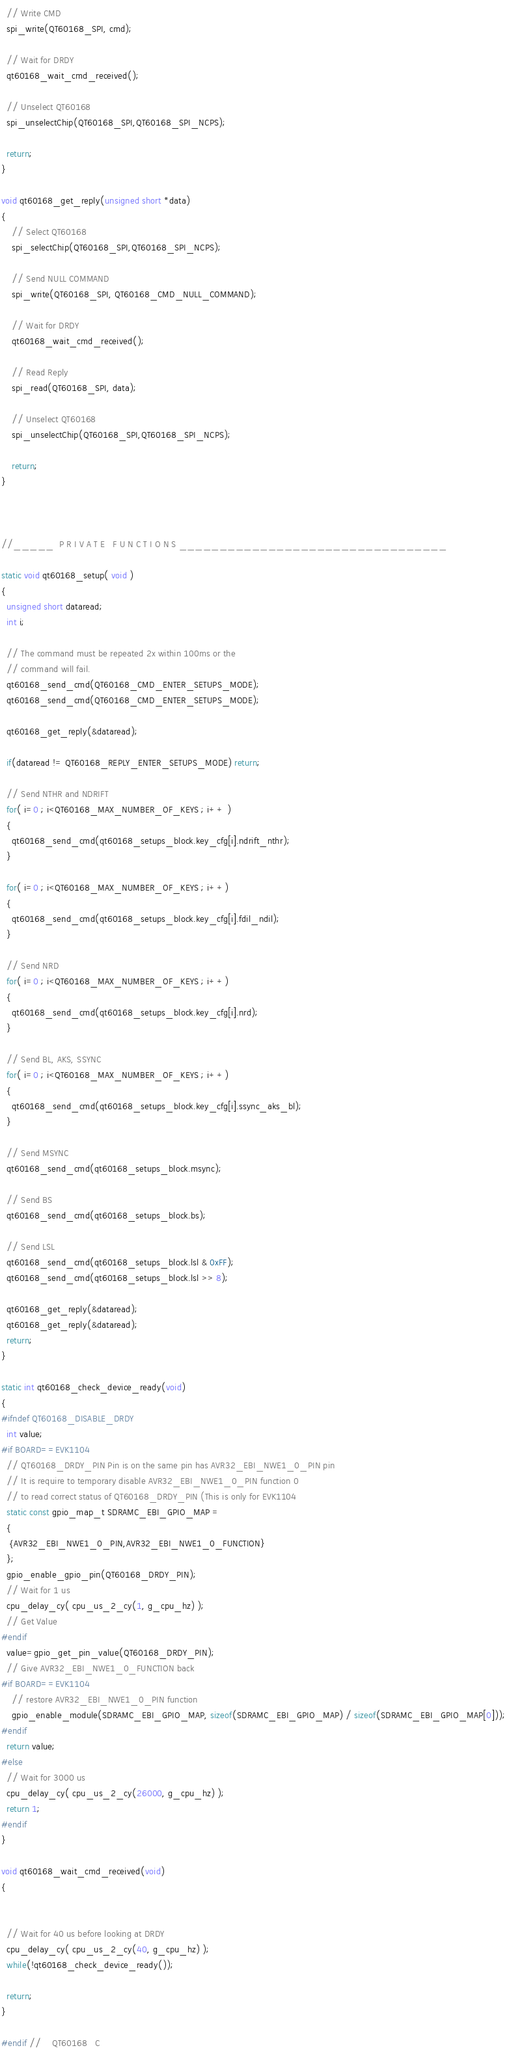Convert code to text. <code><loc_0><loc_0><loc_500><loc_500><_C_>  // Write CMD
  spi_write(QT60168_SPI, cmd);

  // Wait for DRDY
  qt60168_wait_cmd_received();

  // Unselect QT60168
  spi_unselectChip(QT60168_SPI,QT60168_SPI_NCPS);

  return;
}

void qt60168_get_reply(unsigned short *data)
{
    // Select QT60168
    spi_selectChip(QT60168_SPI,QT60168_SPI_NCPS);

    // Send NULL COMMAND
    spi_write(QT60168_SPI, QT60168_CMD_NULL_COMMAND);

    // Wait for DRDY
    qt60168_wait_cmd_received();

    // Read Reply
    spi_read(QT60168_SPI, data);

    // Unselect QT60168
    spi_unselectChip(QT60168_SPI,QT60168_SPI_NCPS);

    return;
}



//_____  P R I V A T E   F U N C T I O N S _________________________________

static void qt60168_setup( void )
{
  unsigned short dataread;
  int i;

  // The command must be repeated 2x within 100ms or the
  // command will fail.
  qt60168_send_cmd(QT60168_CMD_ENTER_SETUPS_MODE);
  qt60168_send_cmd(QT60168_CMD_ENTER_SETUPS_MODE);

  qt60168_get_reply(&dataread);

  if(dataread != QT60168_REPLY_ENTER_SETUPS_MODE) return;

  // Send NTHR and NDRIFT
  for( i=0 ; i<QT60168_MAX_NUMBER_OF_KEYS ; i++ )
  {
    qt60168_send_cmd(qt60168_setups_block.key_cfg[i].ndrift_nthr);
  }

  for( i=0 ; i<QT60168_MAX_NUMBER_OF_KEYS ; i++)
  {
    qt60168_send_cmd(qt60168_setups_block.key_cfg[i].fdil_ndil);
  }

  // Send NRD
  for( i=0 ; i<QT60168_MAX_NUMBER_OF_KEYS ; i++)
  {
    qt60168_send_cmd(qt60168_setups_block.key_cfg[i].nrd);
  }

  // Send BL, AKS, SSYNC
  for( i=0 ; i<QT60168_MAX_NUMBER_OF_KEYS ; i++)
  {
    qt60168_send_cmd(qt60168_setups_block.key_cfg[i].ssync_aks_bl);
  }

  // Send MSYNC
  qt60168_send_cmd(qt60168_setups_block.msync);

  // Send BS
  qt60168_send_cmd(qt60168_setups_block.bs);

  // Send LSL
  qt60168_send_cmd(qt60168_setups_block.lsl & 0xFF);
  qt60168_send_cmd(qt60168_setups_block.lsl >> 8);

  qt60168_get_reply(&dataread);
  qt60168_get_reply(&dataread);
  return;
}

static int qt60168_check_device_ready(void)
{
#ifndef QT60168_DISABLE_DRDY
  int value;
#if BOARD==EVK1104
  // QT60168_DRDY_PIN Pin is on the same pin has AVR32_EBI_NWE1_0_PIN pin
  // It is require to temporary disable AVR32_EBI_NWE1_0_PIN function 0
  // to read correct status of QT60168_DRDY_PIN (This is only for EVK1104
  static const gpio_map_t SDRAMC_EBI_GPIO_MAP =
  {
   {AVR32_EBI_NWE1_0_PIN,AVR32_EBI_NWE1_0_FUNCTION}
  };
  gpio_enable_gpio_pin(QT60168_DRDY_PIN);
  // Wait for 1 us
  cpu_delay_cy( cpu_us_2_cy(1, g_cpu_hz) );
  // Get Value
#endif
  value=gpio_get_pin_value(QT60168_DRDY_PIN);
  // Give AVR32_EBI_NWE1_0_FUNCTION back
#if BOARD==EVK1104
    // restore AVR32_EBI_NWE1_0_PIN function
    gpio_enable_module(SDRAMC_EBI_GPIO_MAP, sizeof(SDRAMC_EBI_GPIO_MAP) / sizeof(SDRAMC_EBI_GPIO_MAP[0]));
#endif
  return value;
#else
  // Wait for 3000 us
  cpu_delay_cy( cpu_us_2_cy(26000, g_cpu_hz) );
  return 1;
#endif
}

void qt60168_wait_cmd_received(void)
{


  // Wait for 40 us before looking at DRDY
  cpu_delay_cy( cpu_us_2_cy(40, g_cpu_hz) );
  while(!qt60168_check_device_ready());

  return;
}

#endif // _QT60168_C_
</code> 